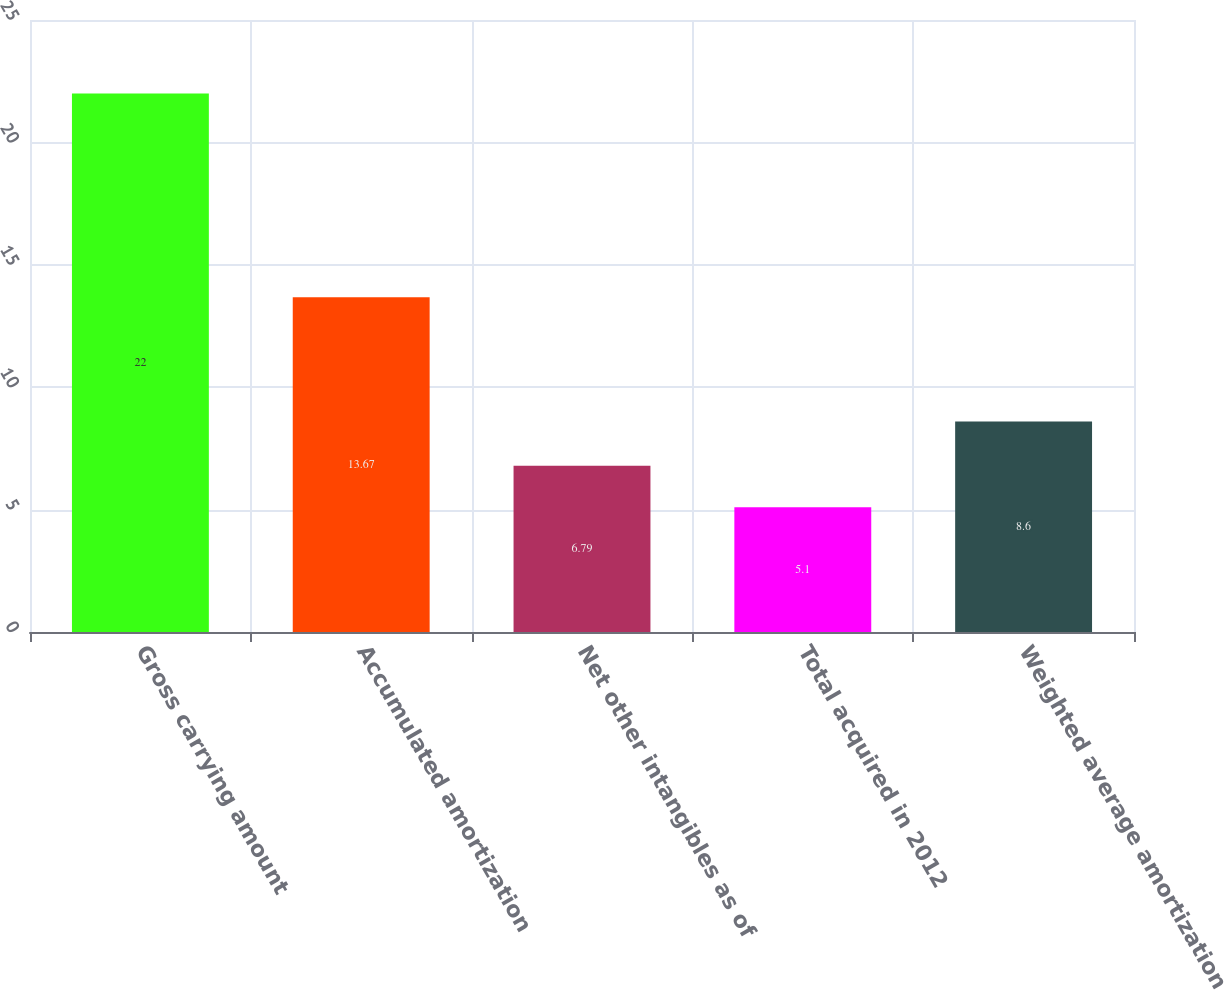<chart> <loc_0><loc_0><loc_500><loc_500><bar_chart><fcel>Gross carrying amount<fcel>Accumulated amortization<fcel>Net other intangibles as of<fcel>Total acquired in 2012<fcel>Weighted average amortization<nl><fcel>22<fcel>13.67<fcel>6.79<fcel>5.1<fcel>8.6<nl></chart> 